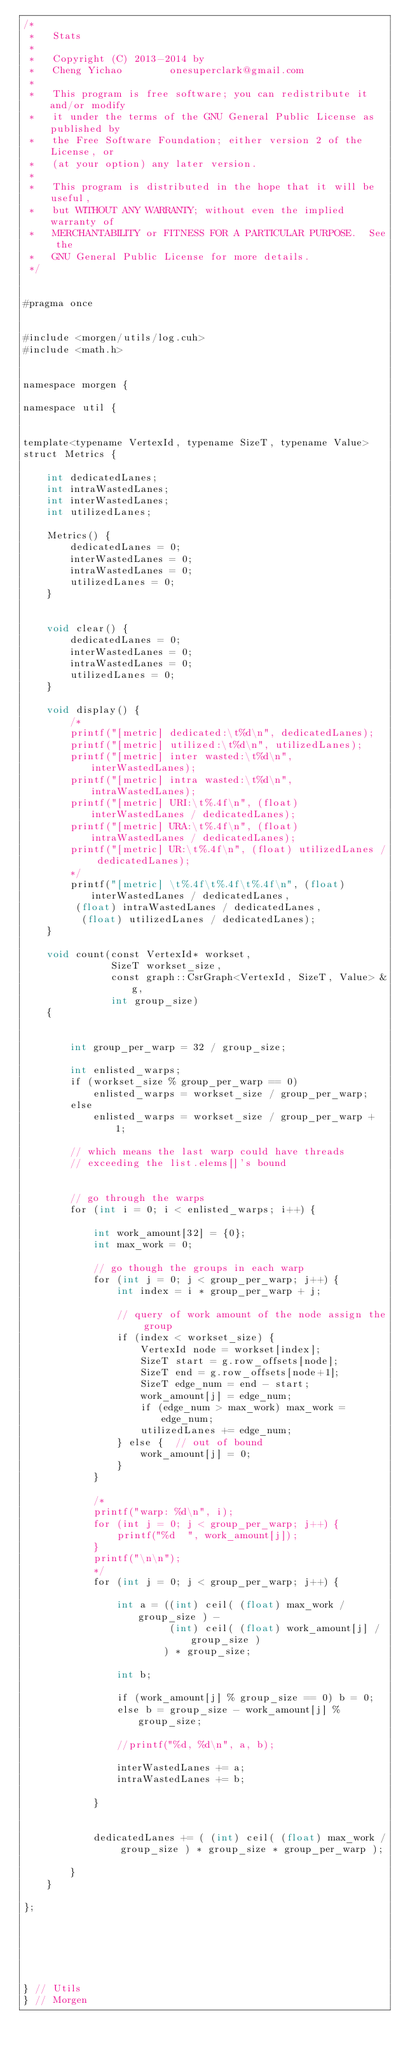Convert code to text. <code><loc_0><loc_0><loc_500><loc_500><_Cuda_>/*
 *   Stats
 *
 *   Copyright (C) 2013-2014 by
 *   Cheng Yichao        onesuperclark@gmail.com
 *
 *   This program is free software; you can redistribute it and/or modify
 *   it under the terms of the GNU General Public License as published by
 *   the Free Software Foundation; either version 2 of the License, or
 *   (at your option) any later version.
 *
 *   This program is distributed in the hope that it will be useful,
 *   but WITHOUT ANY WARRANTY; without even the implied warranty of
 *   MERCHANTABILITY or FITNESS FOR A PARTICULAR PURPOSE.  See the
 *   GNU General Public License for more details.
 */


#pragma once


#include <morgen/utils/log.cuh>
#include <math.h>


namespace morgen {

namespace util {


template<typename VertexId, typename SizeT, typename Value>
struct Metrics {

    int dedicatedLanes;
    int intraWastedLanes;
    int interWastedLanes;
    int utilizedLanes;

    Metrics() {
        dedicatedLanes = 0;
        interWastedLanes = 0;
        intraWastedLanes = 0;
        utilizedLanes = 0;
    }


    void clear() {
        dedicatedLanes = 0;
        interWastedLanes = 0;
        intraWastedLanes = 0;
        utilizedLanes = 0; 
    }

    void display() {
        /*
        printf("[metric] dedicated:\t%d\n", dedicatedLanes);
        printf("[metric] utilized:\t%d\n", utilizedLanes);
        printf("[metric] inter wasted:\t%d\n", interWastedLanes);
        printf("[metric] intra wasted:\t%d\n", intraWastedLanes);
        printf("[metric] URI:\t%.4f\n", (float) interWastedLanes / dedicatedLanes);
        printf("[metric] URA:\t%.4f\n", (float) intraWastedLanes / dedicatedLanes);
        printf("[metric] UR:\t%.4f\n", (float) utilizedLanes / dedicatedLanes);
        */
        printf("[metric] \t%.4f\t%.4f\t%.4f\n", (float) interWastedLanes / dedicatedLanes,
         (float) intraWastedLanes / dedicatedLanes,
          (float) utilizedLanes / dedicatedLanes);
    }

    void count(const VertexId* workset,
               SizeT workset_size,
               const graph::CsrGraph<VertexId, SizeT, Value> &g,
               int group_size) 
    {


        int group_per_warp = 32 / group_size;

        int enlisted_warps;
        if (workset_size % group_per_warp == 0)
            enlisted_warps = workset_size / group_per_warp;
        else 
            enlisted_warps = workset_size / group_per_warp + 1;

        // which means the last warp could have threads
        // exceeding the list.elems[]'s bound


        // go through the warps
        for (int i = 0; i < enlisted_warps; i++) {

            int work_amount[32] = {0};
            int max_work = 0;

            // go though the groups in each warp
            for (int j = 0; j < group_per_warp; j++) {
                int index = i * group_per_warp + j;

                // query of work amount of the node assign the group
                if (index < workset_size) {
                    VertexId node = workset[index];
                    SizeT start = g.row_offsets[node];
                    SizeT end = g.row_offsets[node+1];
                    SizeT edge_num = end - start;
                    work_amount[j] = edge_num;
                    if (edge_num > max_work) max_work = edge_num;
                    utilizedLanes += edge_num;
                } else {  // out of bound
                    work_amount[j] = 0;
                }
            }

            /*
            printf("warp: %d\n", i);
            for (int j = 0; j < group_per_warp; j++) {
                printf("%d  ", work_amount[j]);
            }
            printf("\n\n");
            */
            for (int j = 0; j < group_per_warp; j++) {

                int a = ((int) ceil( (float) max_work / group_size ) -
                         (int) ceil( (float) work_amount[j] / group_size )
                        ) * group_size;

                int b;

                if (work_amount[j] % group_size == 0) b = 0;
                else b = group_size - work_amount[j] % group_size;

                //printf("%d, %d\n", a, b);

                interWastedLanes += a;
                intraWastedLanes += b;

            }
            

            dedicatedLanes += ( (int) ceil( (float) max_work / group_size ) * group_size * group_per_warp );

        }
    }

};






} // Utils
} // Morgen</code> 